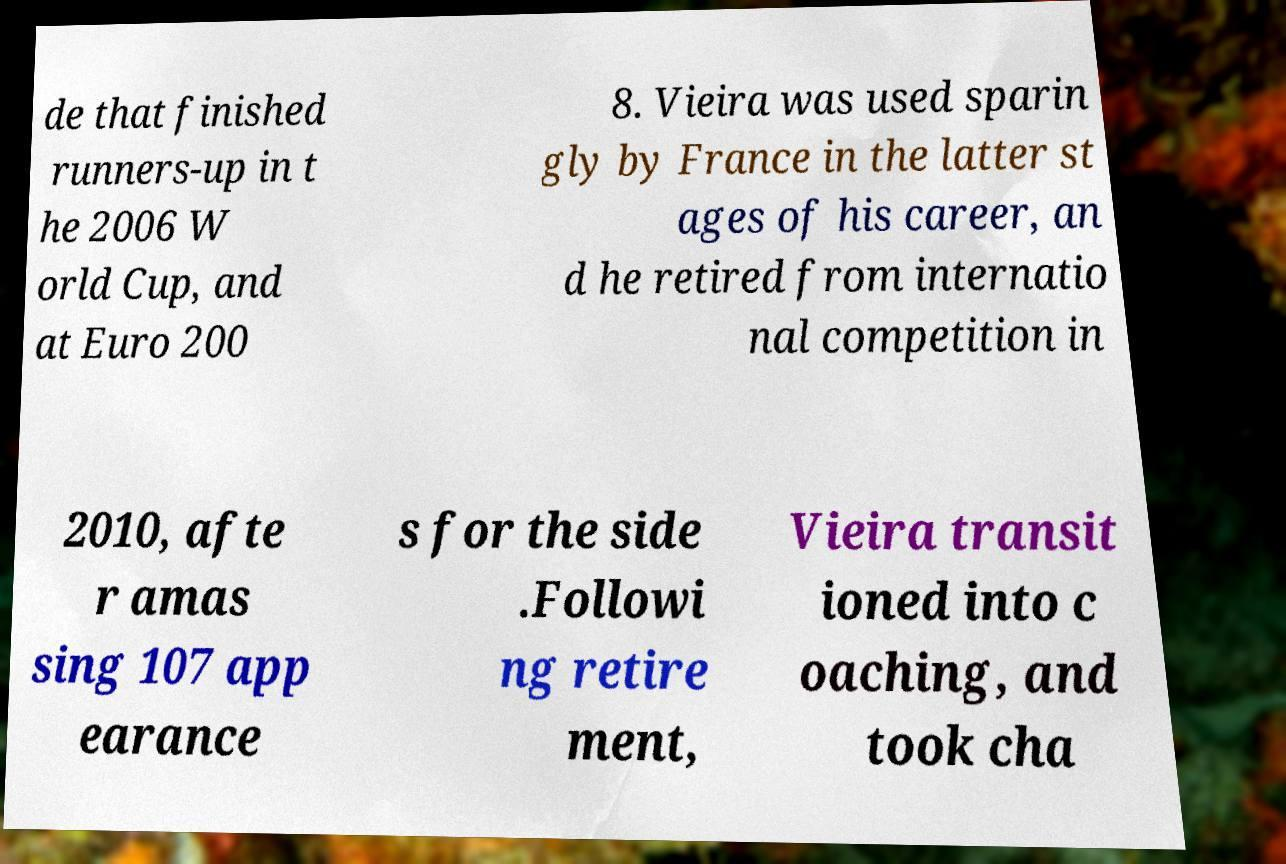Can you read and provide the text displayed in the image?This photo seems to have some interesting text. Can you extract and type it out for me? de that finished runners-up in t he 2006 W orld Cup, and at Euro 200 8. Vieira was used sparin gly by France in the latter st ages of his career, an d he retired from internatio nal competition in 2010, afte r amas sing 107 app earance s for the side .Followi ng retire ment, Vieira transit ioned into c oaching, and took cha 